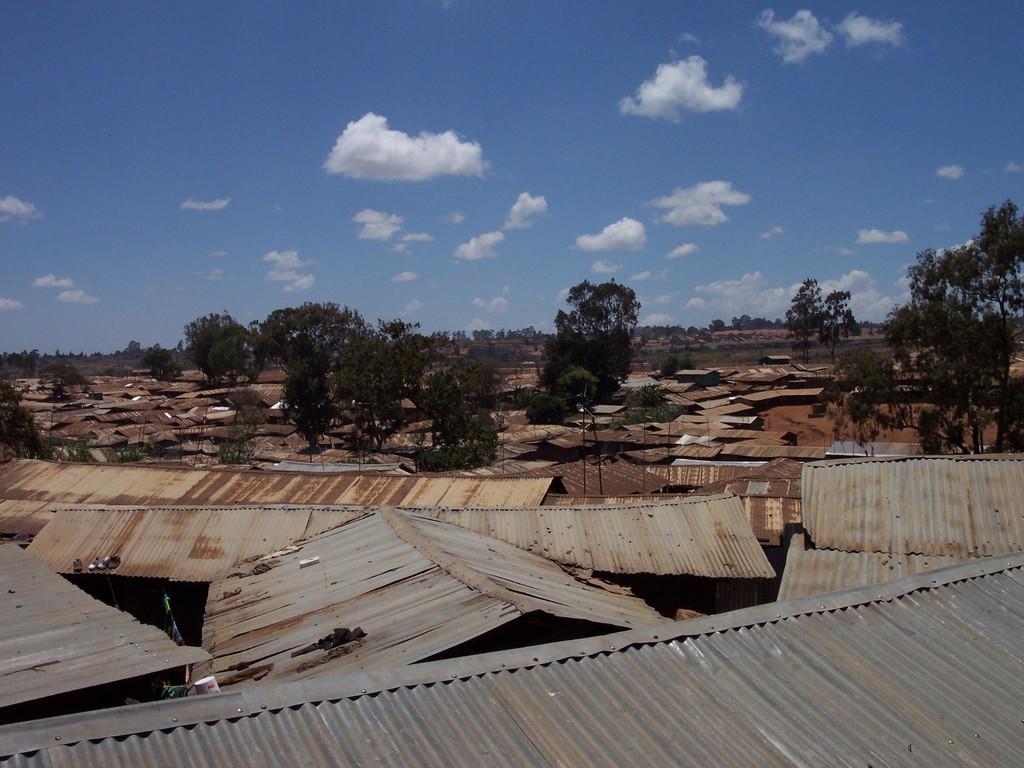Could you give a brief overview of what you see in this image? In this image at the bottom we can see metal sheets as roof on the houses and there are trees. In the background we can see trees and clouds in the sky. 